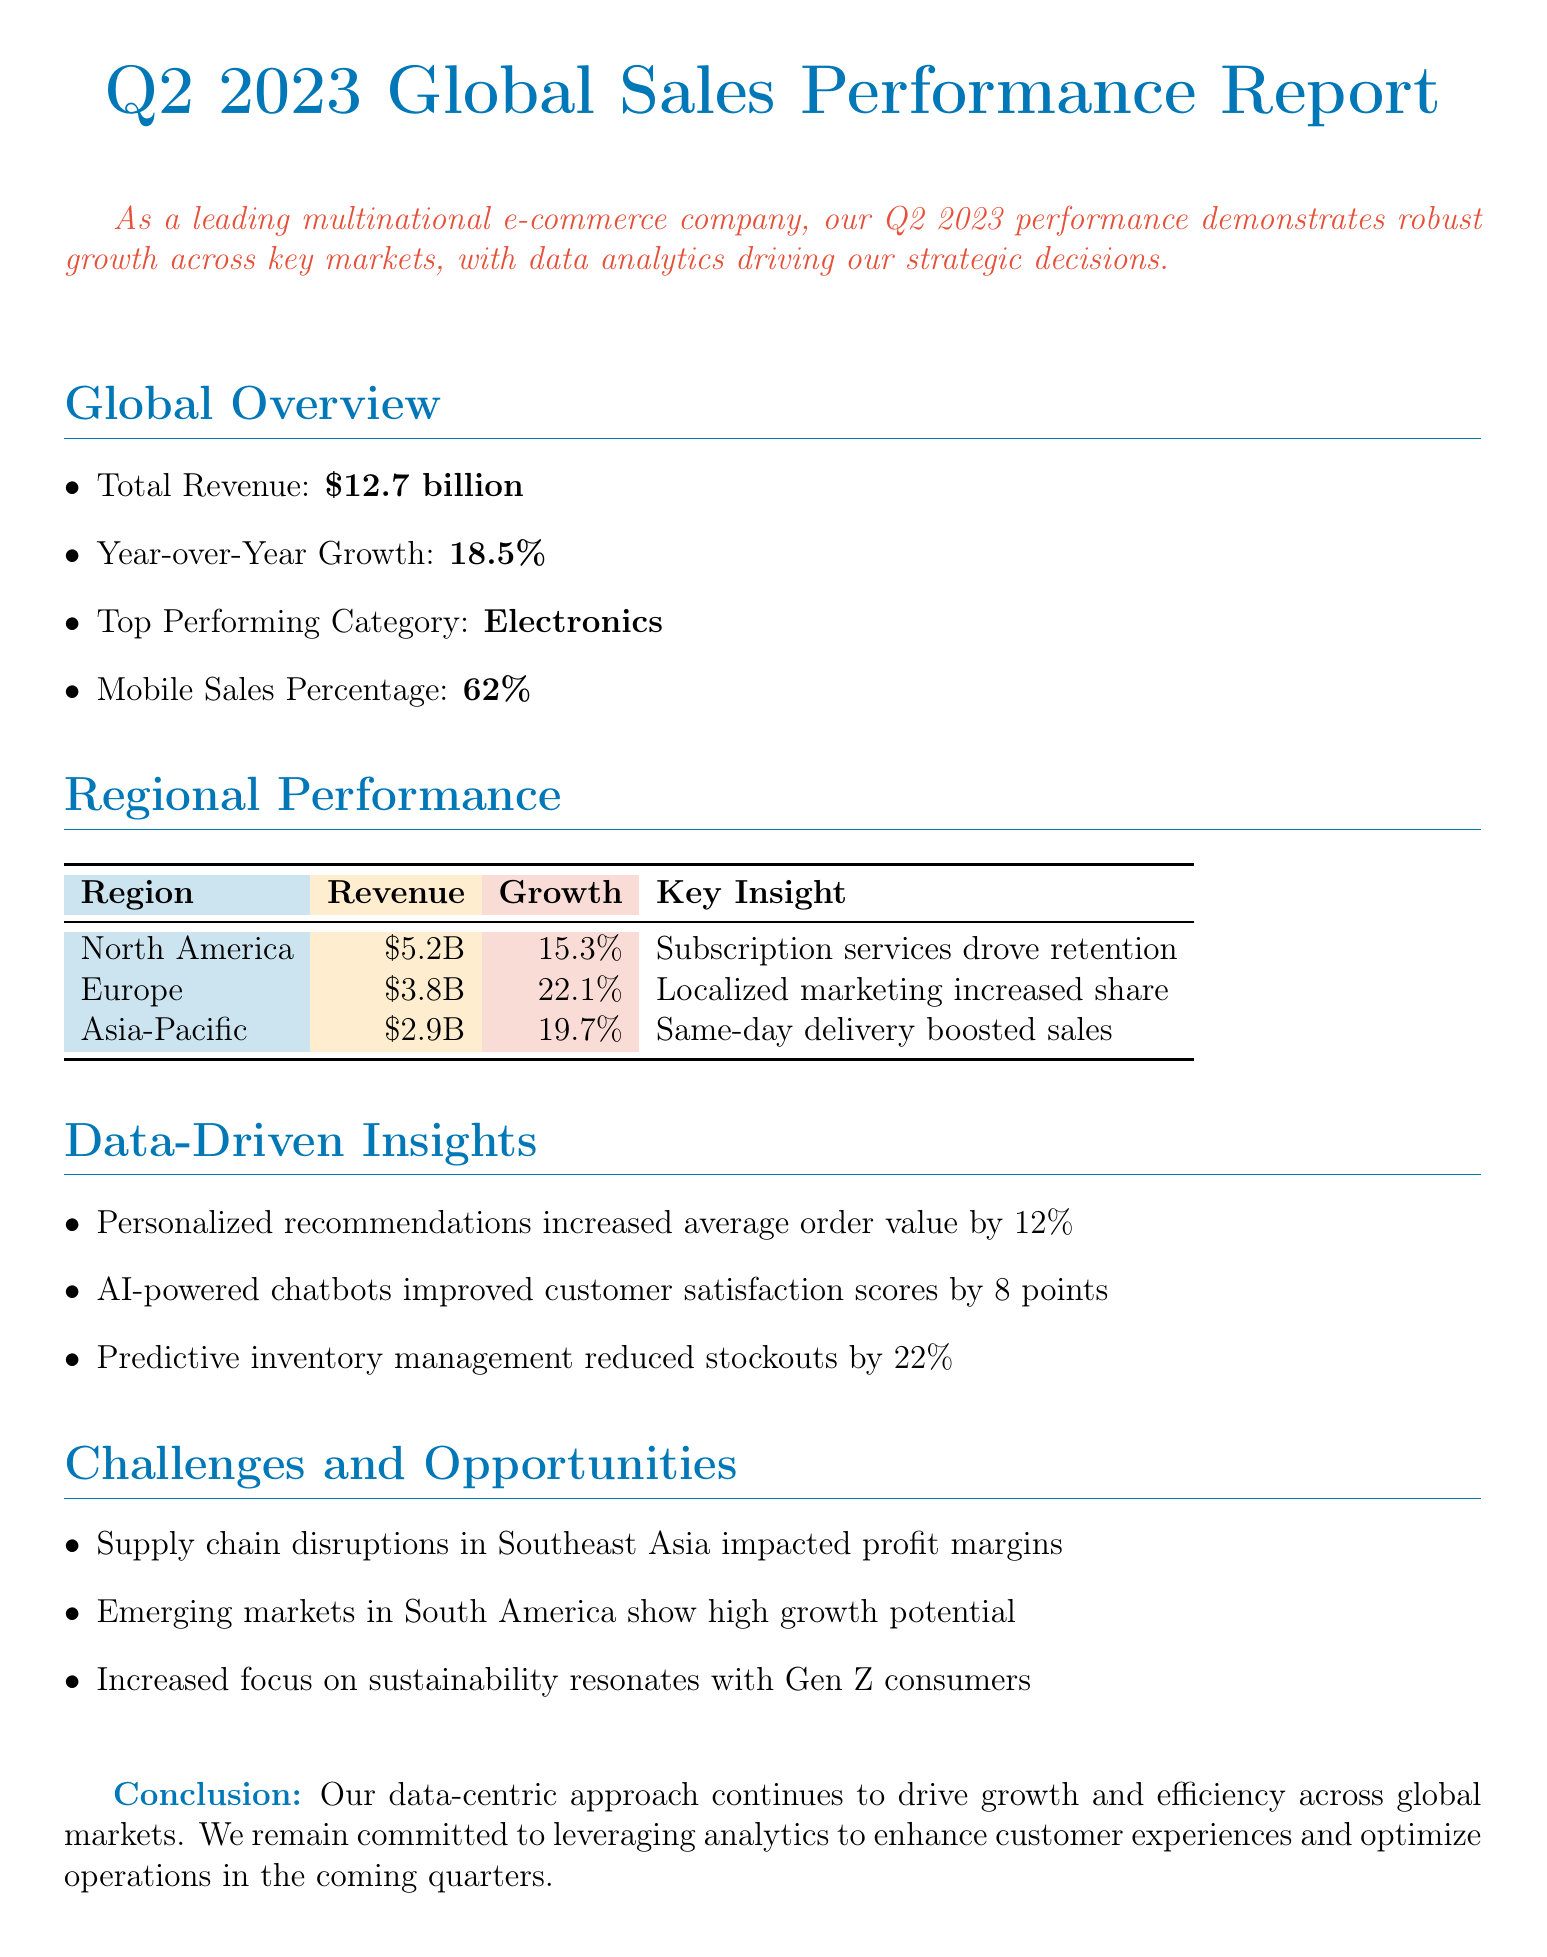what is the total revenue? The total revenue is stated as $12.7 billion in the global overview section of the document.
Answer: $12.7 billion what is the year-over-year growth rate? The year-over-year growth rate is listed as 18.5% in the global overview section.
Answer: 18.5% which category is the top performing? The top performing category is identified as Electronics in the global overview.
Answer: Electronics what is the revenue from Europe? The revenue generated from Europe is reported as $3.8 billion in the regional performance section.
Answer: $3.8 billion what drove customer retention in North America? The key insight for North America indicates that Subscription-based services drove customer retention.
Answer: Subscription-based services how much did personalized recommendations increase average order value? The document states that personalized product recommendations increased average order value by 12%.
Answer: 12% what was the growth rate for Asia-Pacific? The growth rate for Asia-Pacific is documented as 19.7% in the regional performance section.
Answer: 19.7% what is the major challenge mentioned in the report? One major challenge mentioned is supply chain disruptions in Southeast Asia.
Answer: Supply chain disruptions how is sustainability viewed by Gen Z consumers? The report mentions that an increased focus on sustainability resonates with Gen Z consumers.
Answer: Resonates with Gen Z consumers 